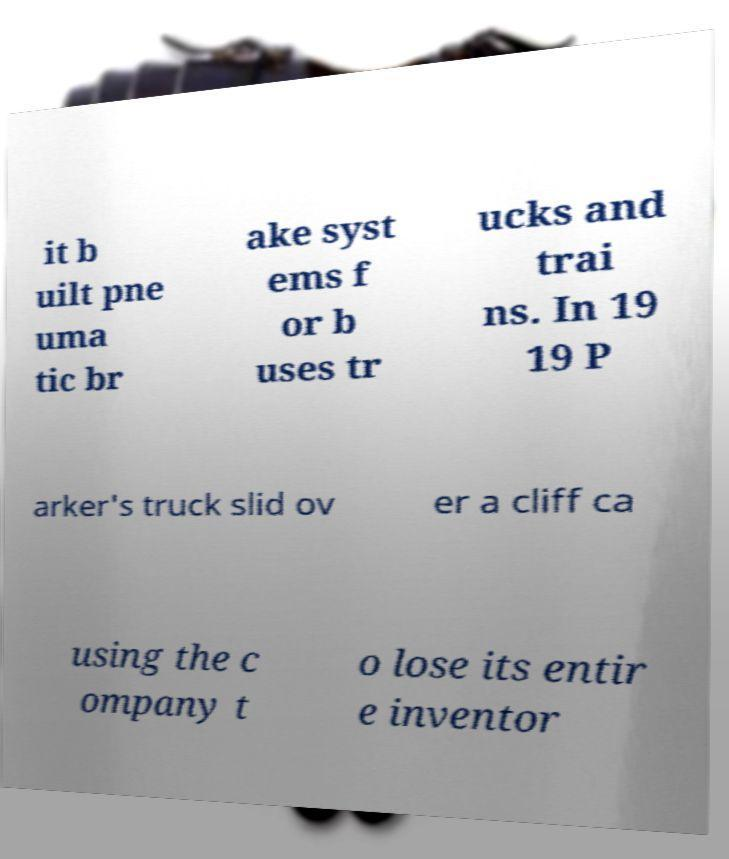Could you assist in decoding the text presented in this image and type it out clearly? it b uilt pne uma tic br ake syst ems f or b uses tr ucks and trai ns. In 19 19 P arker's truck slid ov er a cliff ca using the c ompany t o lose its entir e inventor 